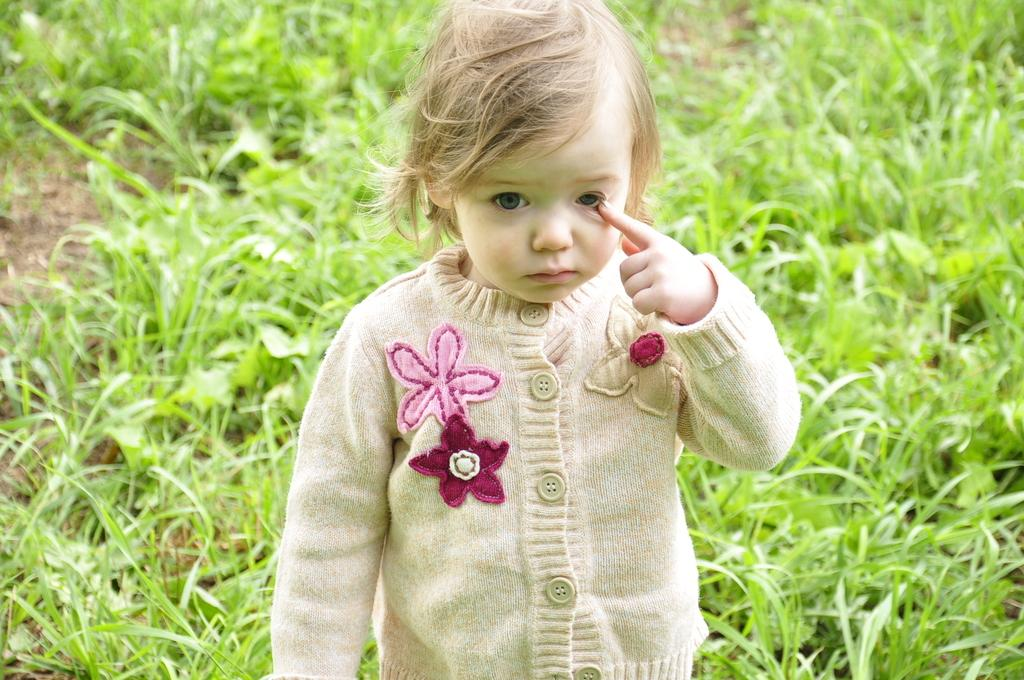Who is the main subject in the image? There is a girl in the image. What is the girl doing in the image? The girl is standing. What type of environment is visible in the background of the image? There is grass visible in the background of the image. What type of picture is the girl holding during the rainstorm? There is no picture or rainstorm present in the image; it features a girl standing in front of grass. 